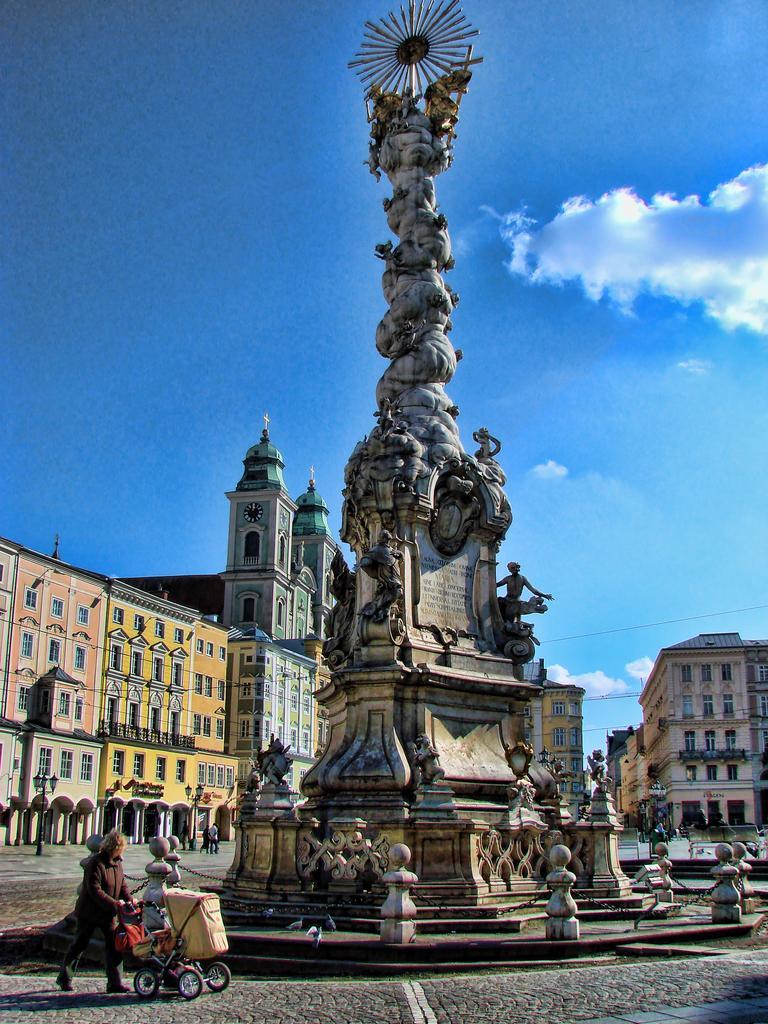In one or two sentences, can you explain what this image depicts? Here in the middle we can see a statue present on the ground over there and on the road we can see people walking here and there and behind them we can see buildings present all over there and we can see clouds in sky over there. 